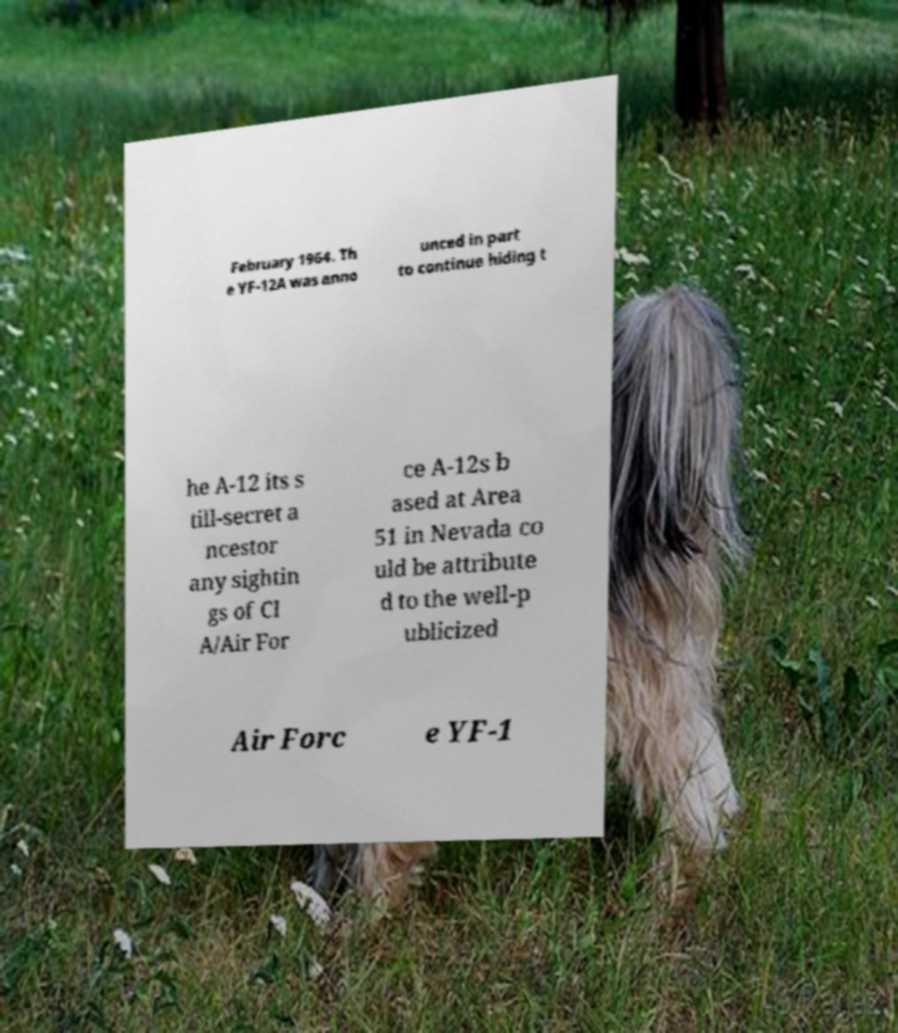Please identify and transcribe the text found in this image. February 1964. Th e YF-12A was anno unced in part to continue hiding t he A-12 its s till-secret a ncestor any sightin gs of CI A/Air For ce A-12s b ased at Area 51 in Nevada co uld be attribute d to the well-p ublicized Air Forc e YF-1 